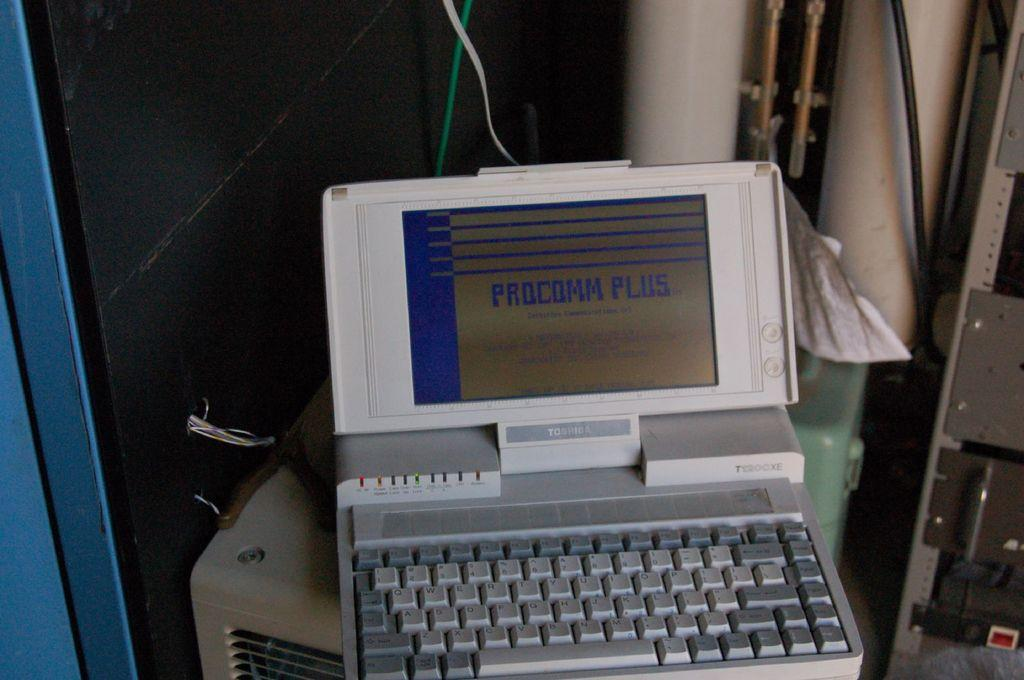<image>
Describe the image concisely. Small Toshiba laptop with a screen that says Procomm. 